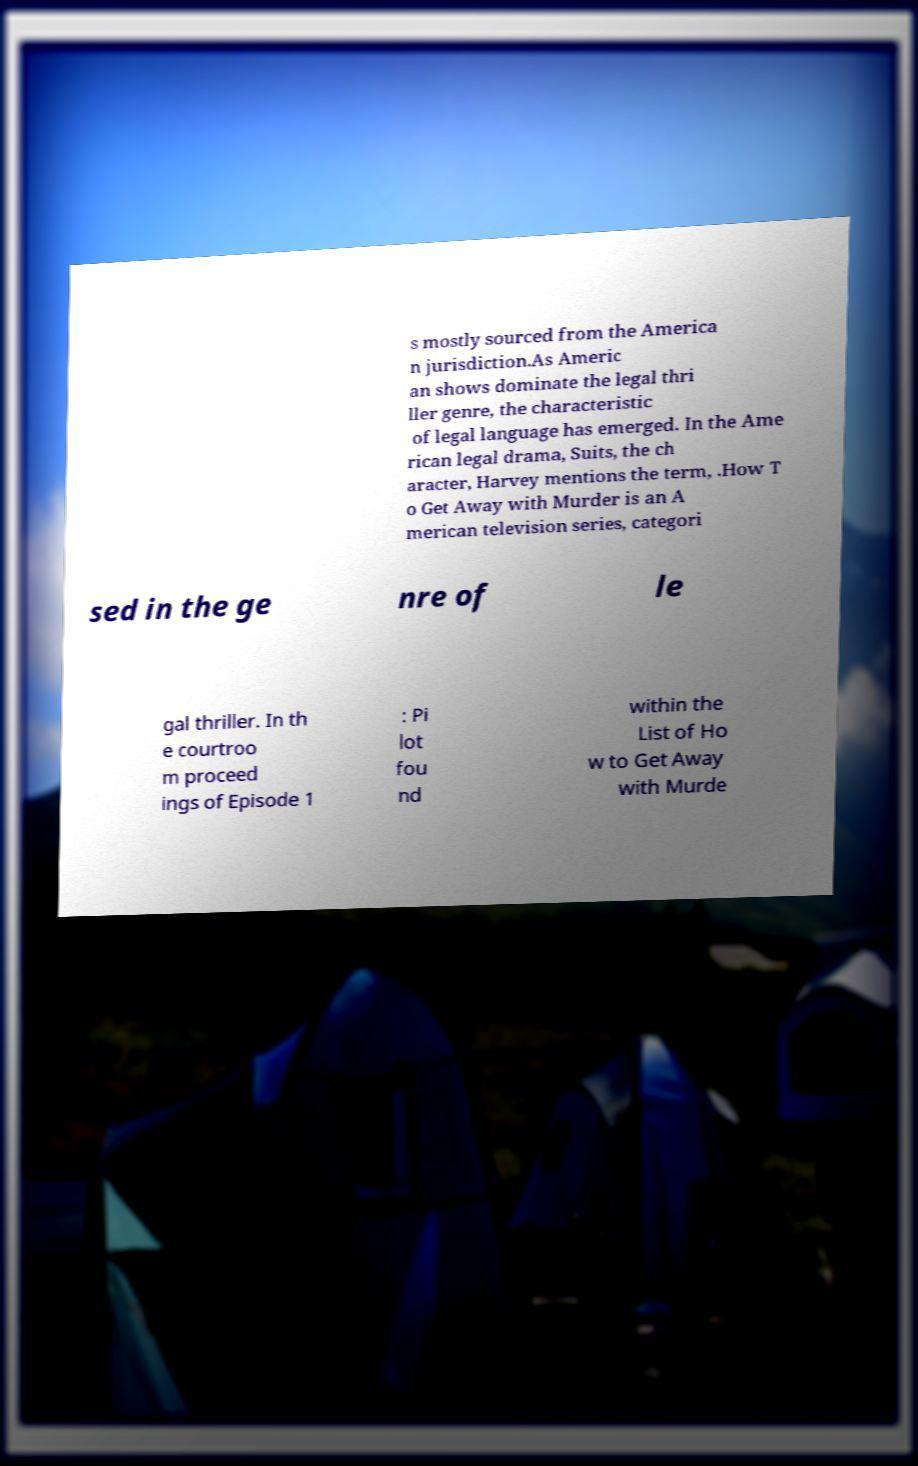Please read and relay the text visible in this image. What does it say? s mostly sourced from the America n jurisdiction.As Americ an shows dominate the legal thri ller genre, the characteristic of legal language has emerged. In the Ame rican legal drama, Suits, the ch aracter, Harvey mentions the term, .How T o Get Away with Murder is an A merican television series, categori sed in the ge nre of le gal thriller. In th e courtroo m proceed ings of Episode 1 : Pi lot fou nd within the List of Ho w to Get Away with Murde 